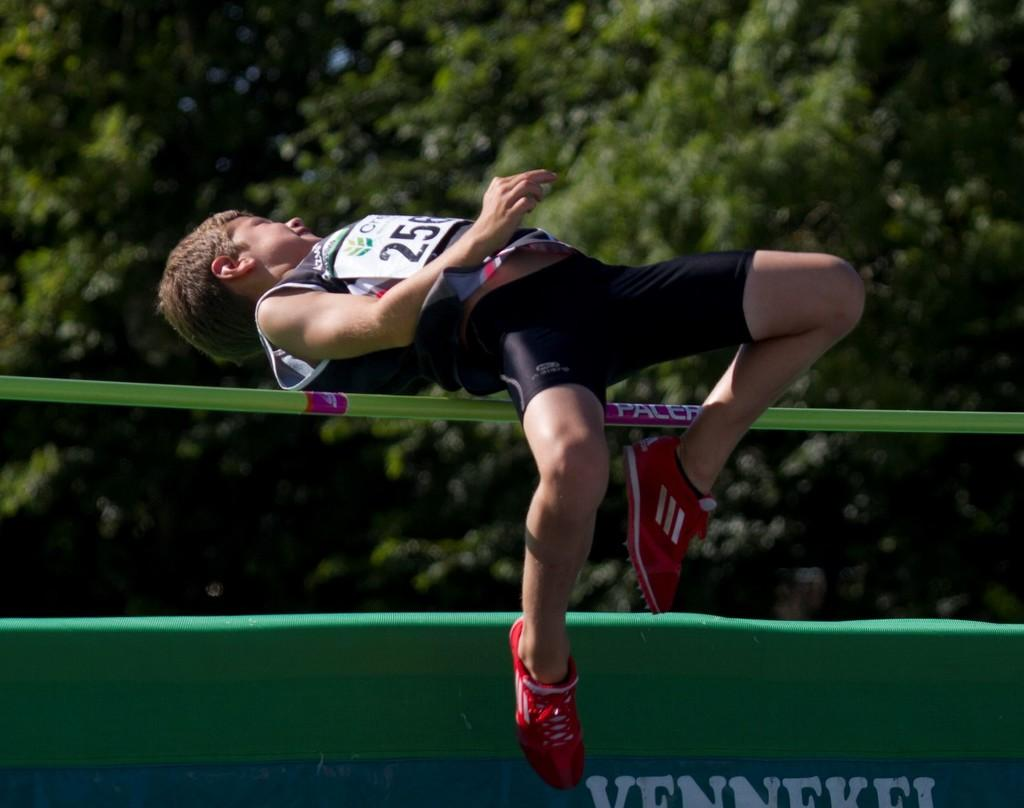Provide a one-sentence caption for the provided image. A man wearing bib number 256 is jumping over a high jump bar. 